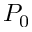Convert formula to latex. <formula><loc_0><loc_0><loc_500><loc_500>P _ { 0 }</formula> 